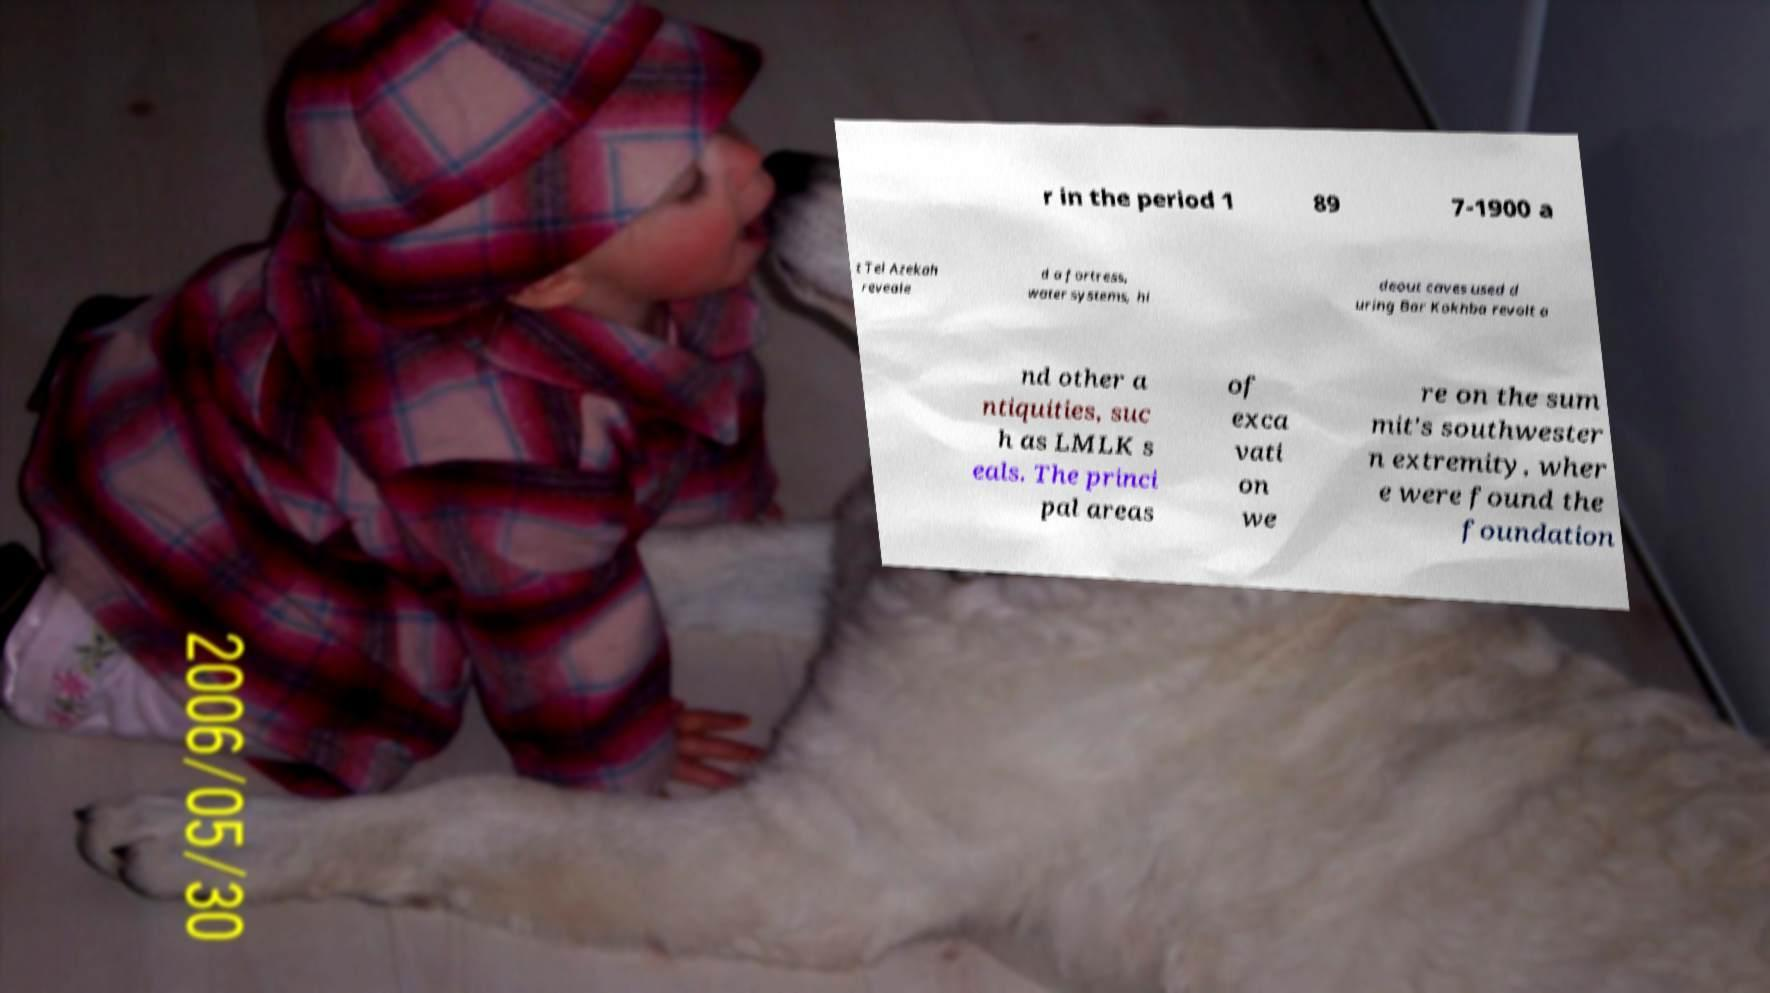There's text embedded in this image that I need extracted. Can you transcribe it verbatim? r in the period 1 89 7-1900 a t Tel Azekah reveale d a fortress, water systems, hi deout caves used d uring Bar Kokhba revolt a nd other a ntiquities, suc h as LMLK s eals. The princi pal areas of exca vati on we re on the sum mit's southwester n extremity, wher e were found the foundation 